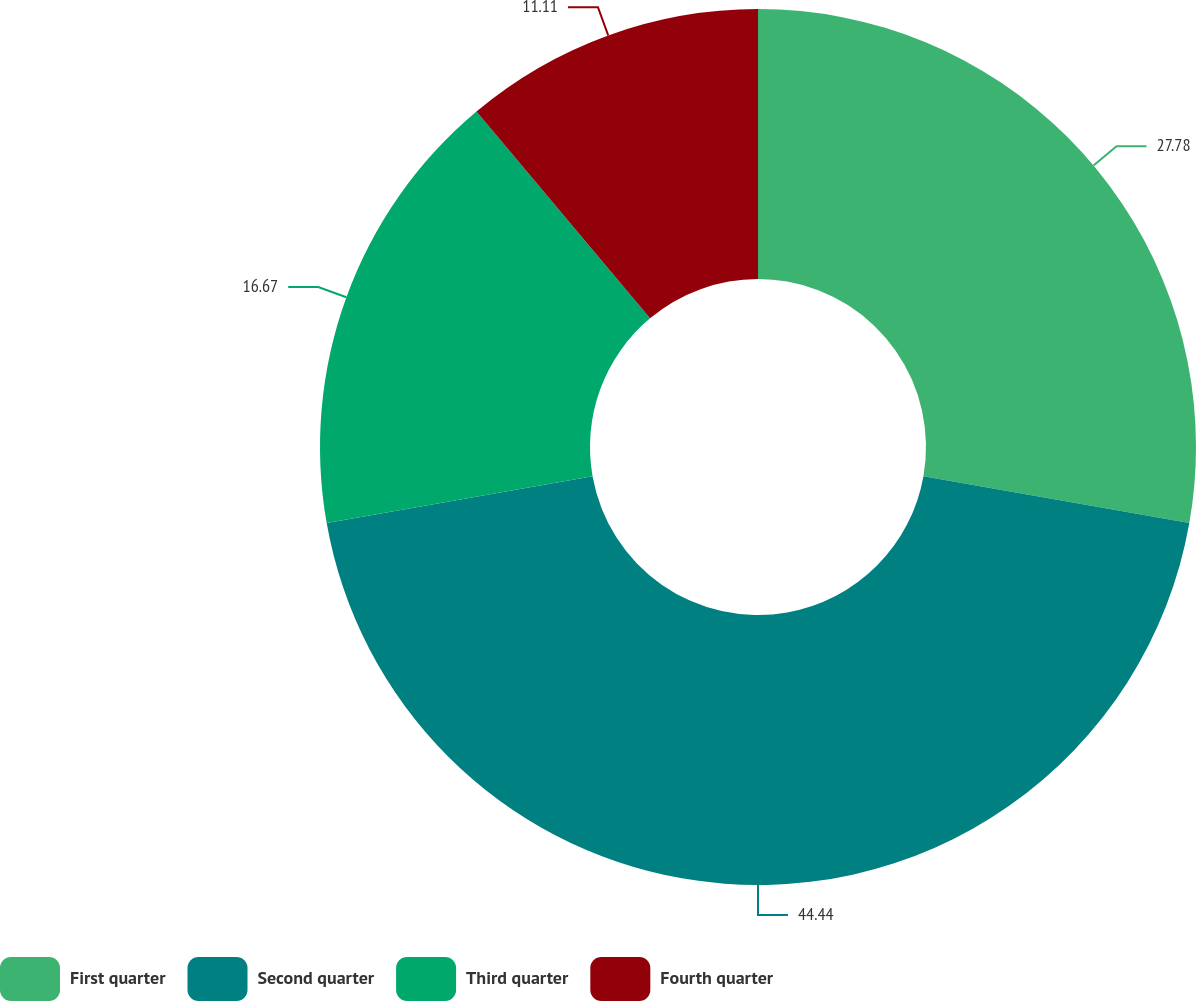Convert chart to OTSL. <chart><loc_0><loc_0><loc_500><loc_500><pie_chart><fcel>First quarter<fcel>Second quarter<fcel>Third quarter<fcel>Fourth quarter<nl><fcel>27.78%<fcel>44.44%<fcel>16.67%<fcel>11.11%<nl></chart> 